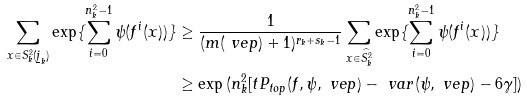Convert formula to latex. <formula><loc_0><loc_0><loc_500><loc_500>\sum _ { x \in S _ { k } ^ { 2 } ( \underline { j } _ { k } ) } \exp \{ \sum _ { i = 0 } ^ { n _ { k } ^ { 2 } - 1 } \psi ( f ^ { i } ( x ) ) \} & \geq \frac { 1 } { ( m ( \ v e p ) + 1 ) ^ { r _ { k } + s _ { k } - 1 } } \sum _ { x \in \widehat { S _ { k } ^ { 2 } } } \exp \{ \sum _ { i = 0 } ^ { n _ { k } ^ { 2 } - 1 } \psi ( f ^ { i } ( x ) ) \} \\ & \geq \exp \, ( n _ { k } ^ { 2 } [ t P _ { t o p } ( f , \psi , \ v e p ) - \ v a r ( \psi , \ v e p ) - 6 \gamma ] )</formula> 